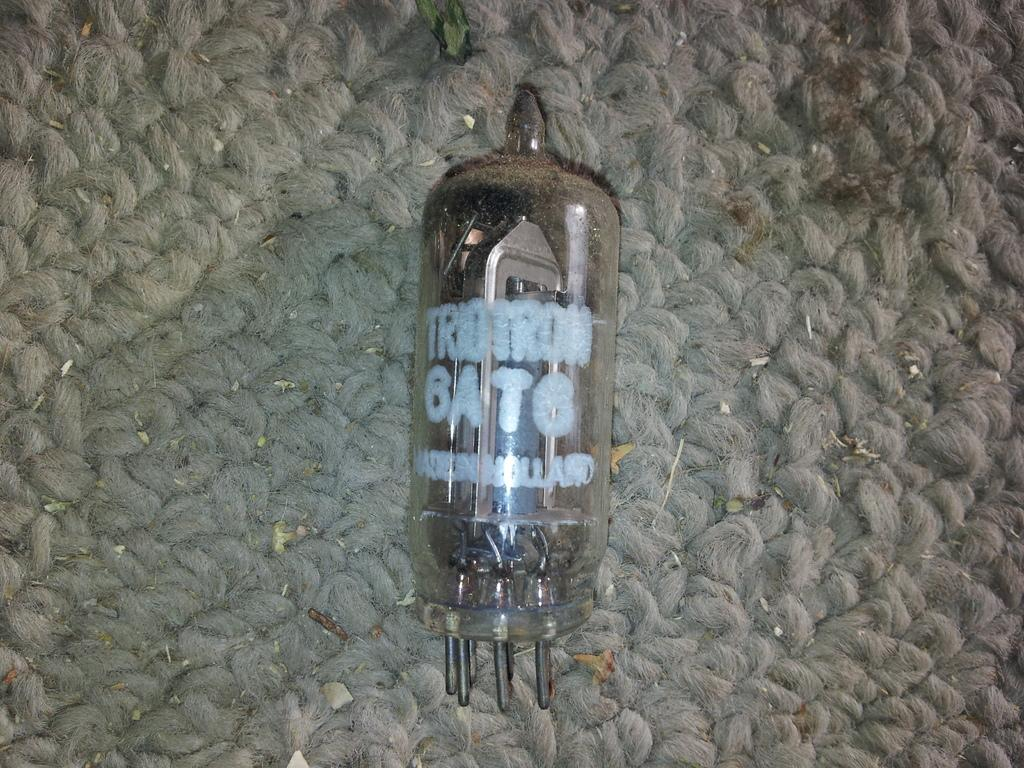What object is visible inside the glass bottle in the image? There are tongs inside the glass bottle in the image. What is the glass bottle placed on in the image? The glass bottle is on a mat in the image. What type of tent can be seen in the image? There is no tent present in the image. What word is written on the glass bottle in the image? There is no word written on the glass bottle in the image. 